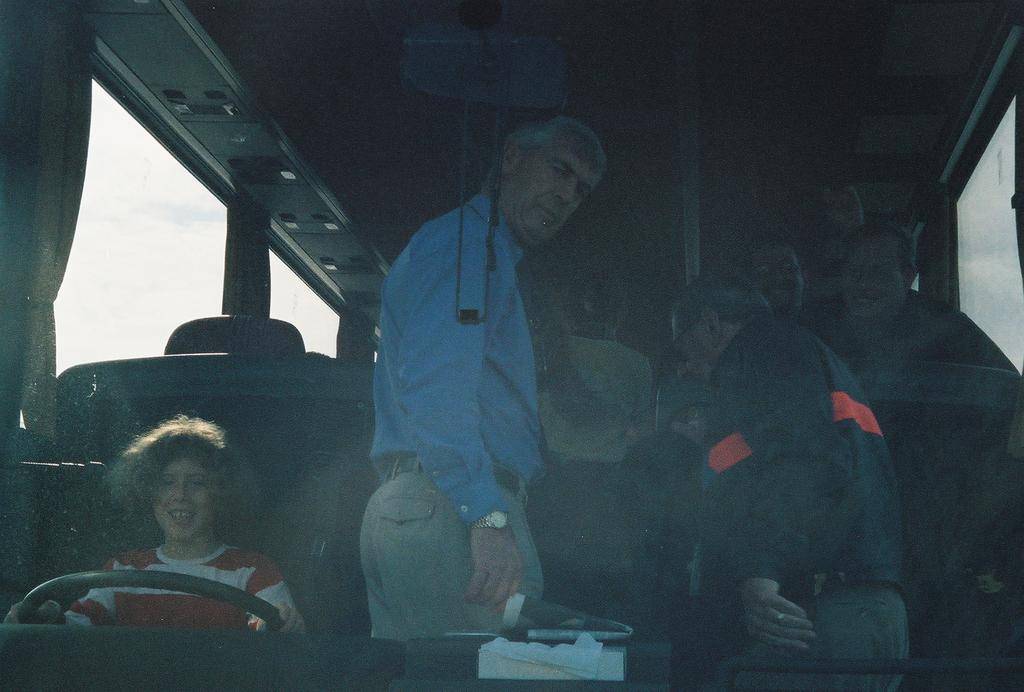What is the setting of the image? The image shows the inside of a vehicle. Who or what can be seen inside the vehicle? There is a group of people in the vehicle. What are the people in the vehicle doing? The people are staring at something. What allows the passengers to see the outside environment? There are windows in the vehicle. What type of vegetable is being used as a cast for the injured person in the image? There is no injured person or vegetable being used as a cast in the image. 